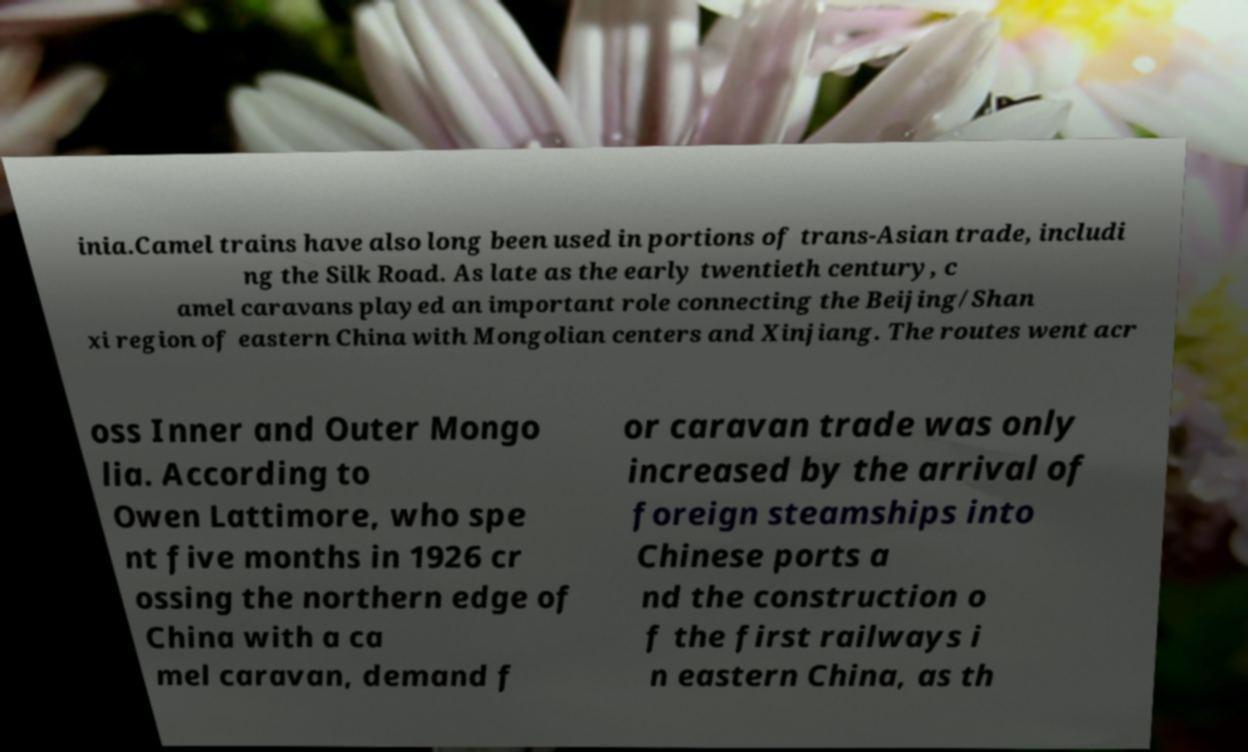Can you read and provide the text displayed in the image?This photo seems to have some interesting text. Can you extract and type it out for me? inia.Camel trains have also long been used in portions of trans-Asian trade, includi ng the Silk Road. As late as the early twentieth century, c amel caravans played an important role connecting the Beijing/Shan xi region of eastern China with Mongolian centers and Xinjiang. The routes went acr oss Inner and Outer Mongo lia. According to Owen Lattimore, who spe nt five months in 1926 cr ossing the northern edge of China with a ca mel caravan, demand f or caravan trade was only increased by the arrival of foreign steamships into Chinese ports a nd the construction o f the first railways i n eastern China, as th 